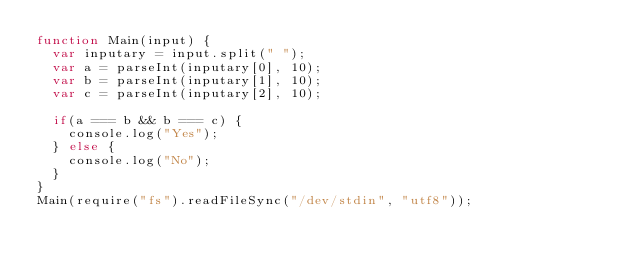Convert code to text. <code><loc_0><loc_0><loc_500><loc_500><_JavaScript_>function Main(input) {
  var inputary = input.split(" ");
  var a = parseInt(inputary[0], 10);
  var b = parseInt(inputary[1], 10);
  var c = parseInt(inputary[2], 10);

  if(a === b && b === c) {
    console.log("Yes");
  } else {
    console.log("No");
  }
}
Main(require("fs").readFileSync("/dev/stdin", "utf8"));</code> 